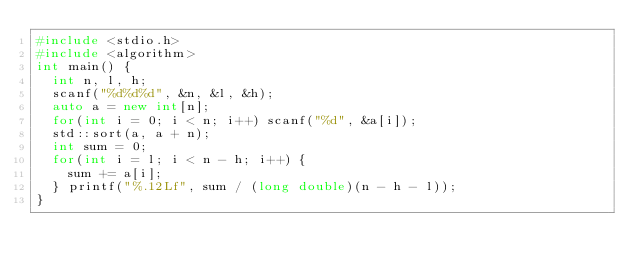<code> <loc_0><loc_0><loc_500><loc_500><_C++_>#include <stdio.h>
#include <algorithm>
int main() {
	int n, l, h;
	scanf("%d%d%d", &n, &l, &h);
	auto a = new int[n];
	for(int i = 0; i < n; i++) scanf("%d", &a[i]);
	std::sort(a, a + n);
	int sum = 0;
	for(int i = l; i < n - h; i++) {
		sum += a[i];
	} printf("%.12Lf", sum / (long double)(n - h - l));
}</code> 